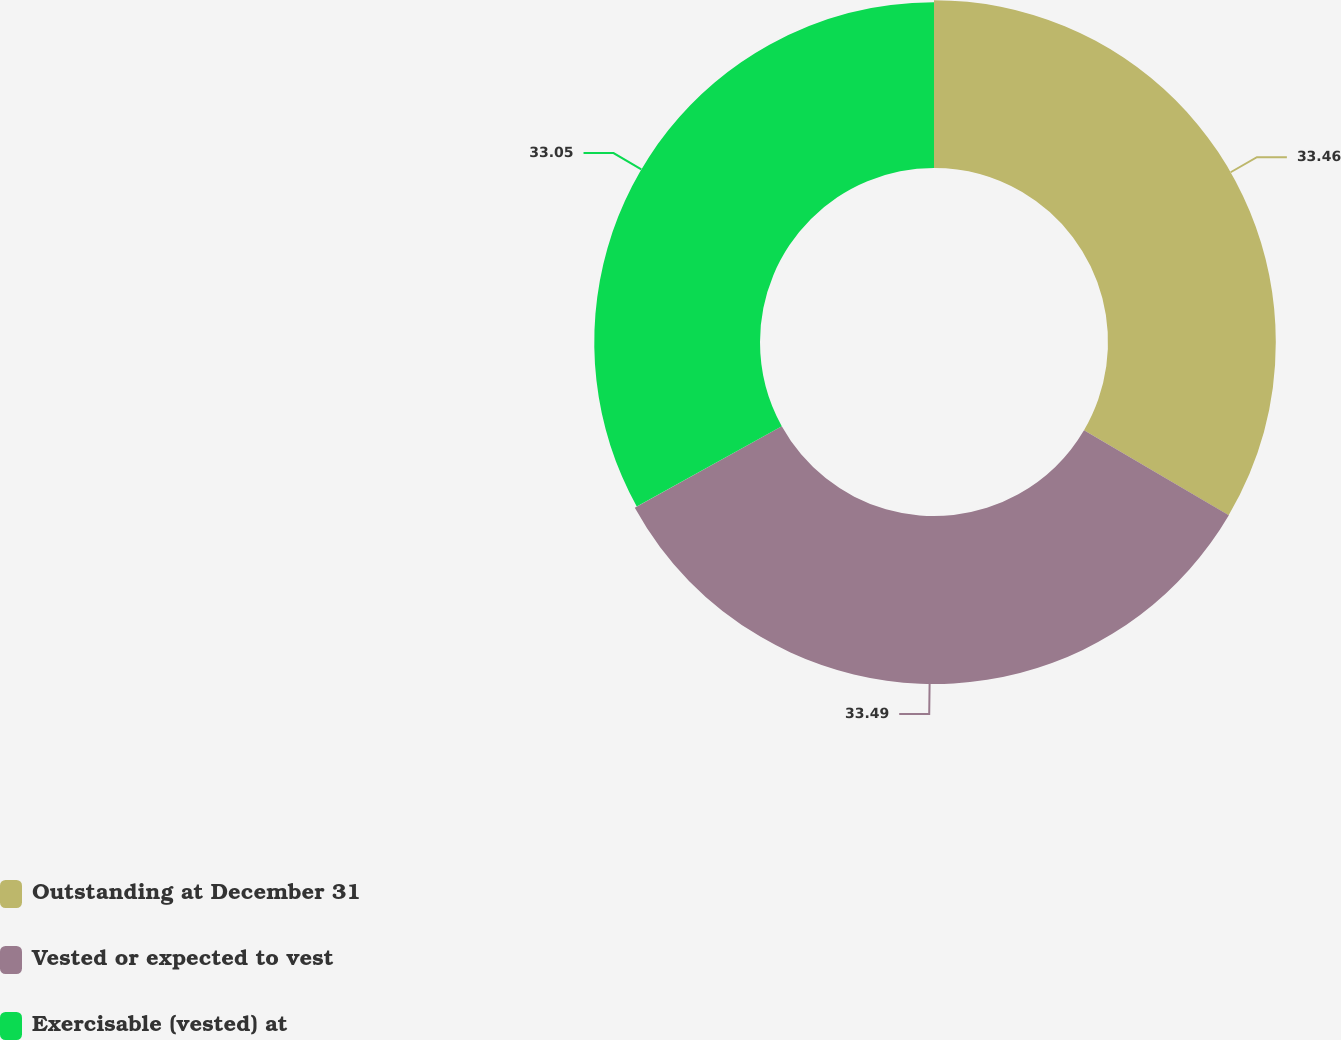Convert chart. <chart><loc_0><loc_0><loc_500><loc_500><pie_chart><fcel>Outstanding at December 31<fcel>Vested or expected to vest<fcel>Exercisable (vested) at<nl><fcel>33.46%<fcel>33.5%<fcel>33.05%<nl></chart> 